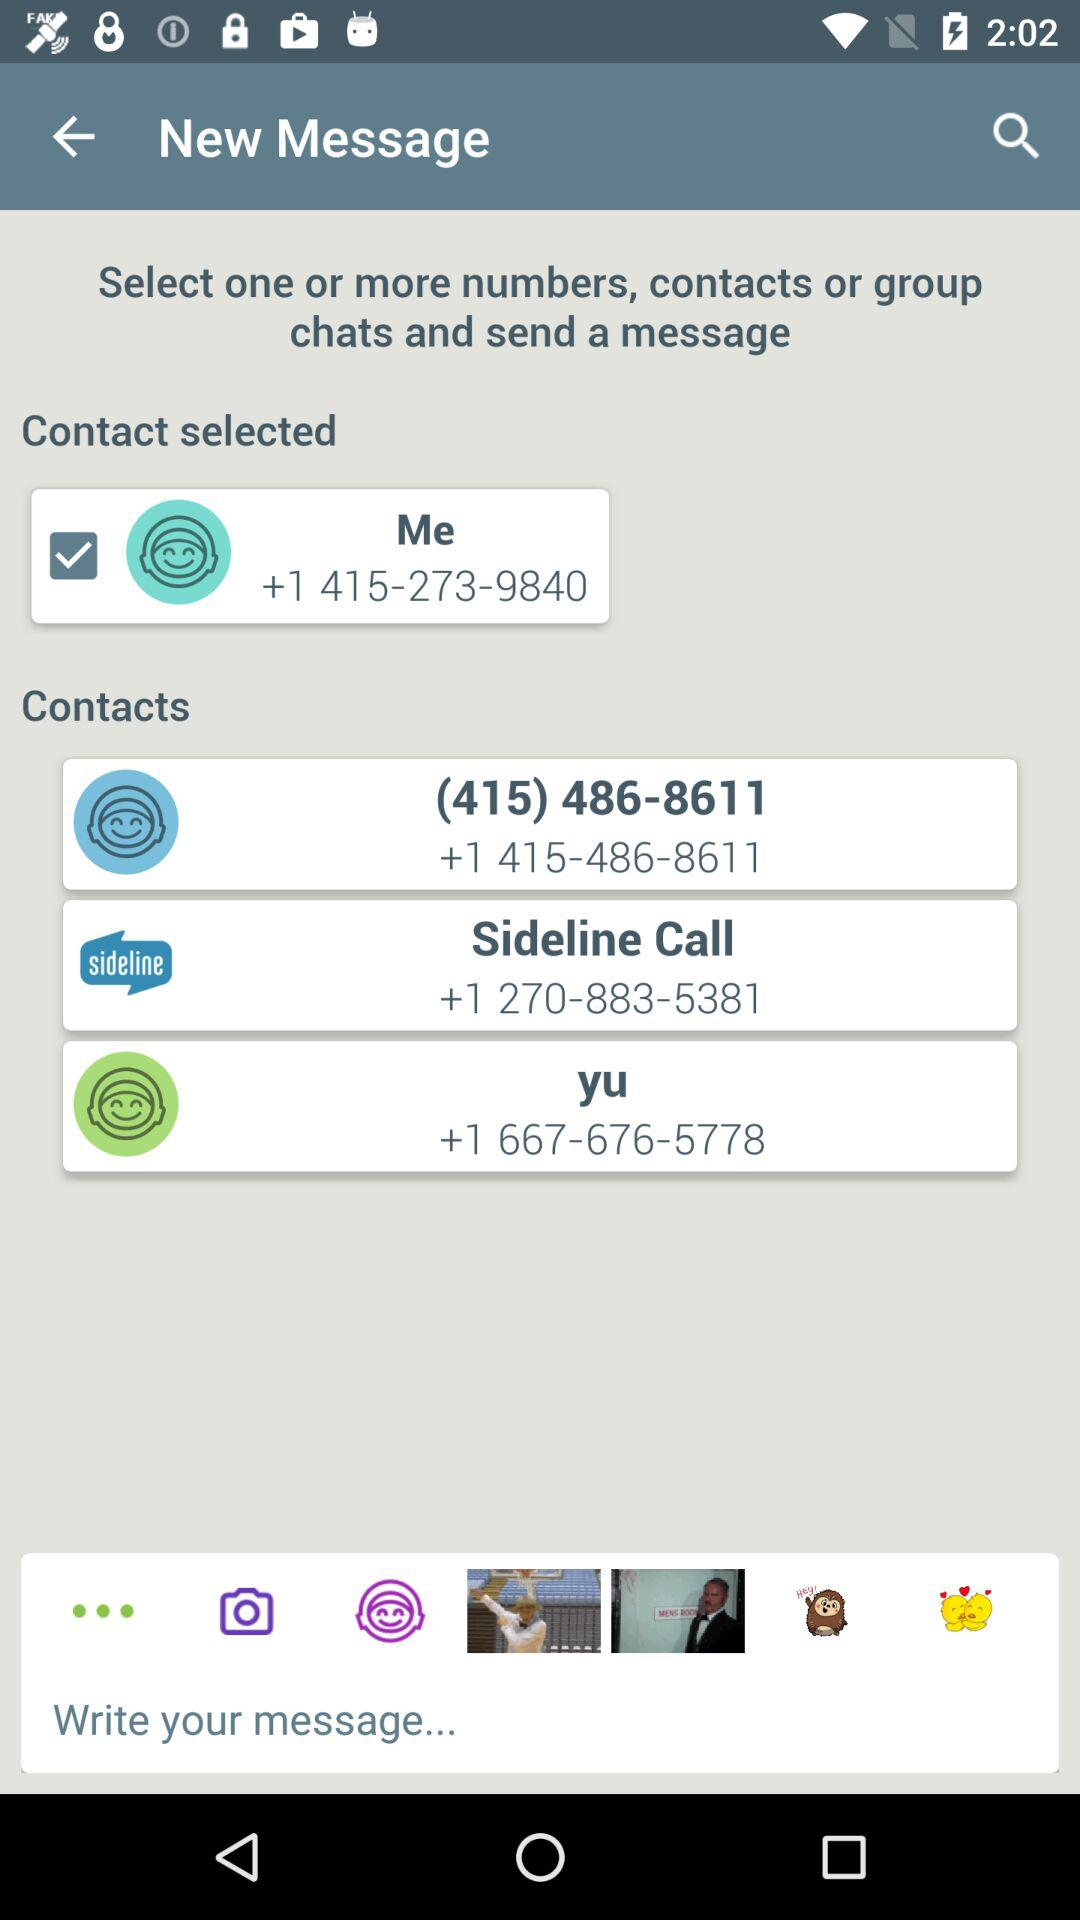What is the selected contact number? The selected contact number is +1 415-273-9840. 